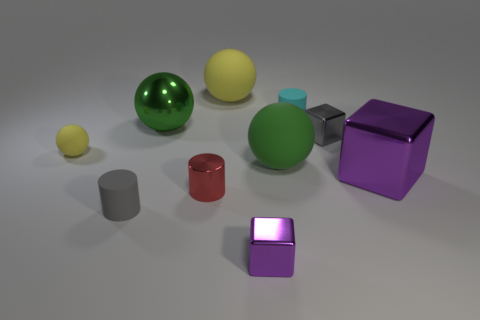How many big objects are both on the right side of the gray metal cube and to the left of the tiny purple thing?
Your answer should be compact. 0. What material is the red cylinder?
Your answer should be compact. Metal. Are there the same number of tiny red objects that are behind the large yellow sphere and small red cylinders?
Provide a succinct answer. No. What number of tiny purple metal objects are the same shape as the cyan matte thing?
Your answer should be very brief. 0. Is the green shiny thing the same shape as the green matte object?
Offer a terse response. Yes. How many objects are either cylinders in front of the large green rubber thing or tiny purple rubber cylinders?
Your answer should be very brief. 2. What is the shape of the large matte object in front of the yellow matte object that is on the right side of the large green object that is to the left of the red cylinder?
Your answer should be compact. Sphere. What is the shape of the tiny yellow thing that is made of the same material as the large yellow object?
Provide a succinct answer. Sphere. The gray matte object has what size?
Keep it short and to the point. Small. Does the gray cylinder have the same size as the red thing?
Keep it short and to the point. Yes. 